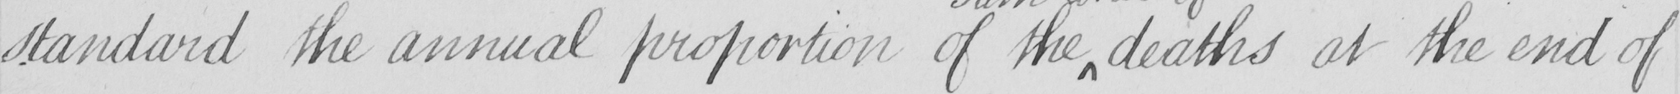Transcribe the text shown in this historical manuscript line. standard the annual proportion of the deaths at the end of 